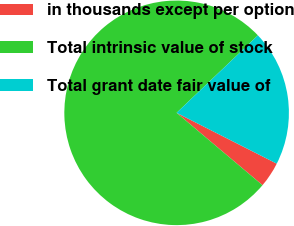Convert chart. <chart><loc_0><loc_0><loc_500><loc_500><pie_chart><fcel>in thousands except per option<fcel>Total intrinsic value of stock<fcel>Total grant date fair value of<nl><fcel>3.67%<fcel>76.74%<fcel>19.59%<nl></chart> 